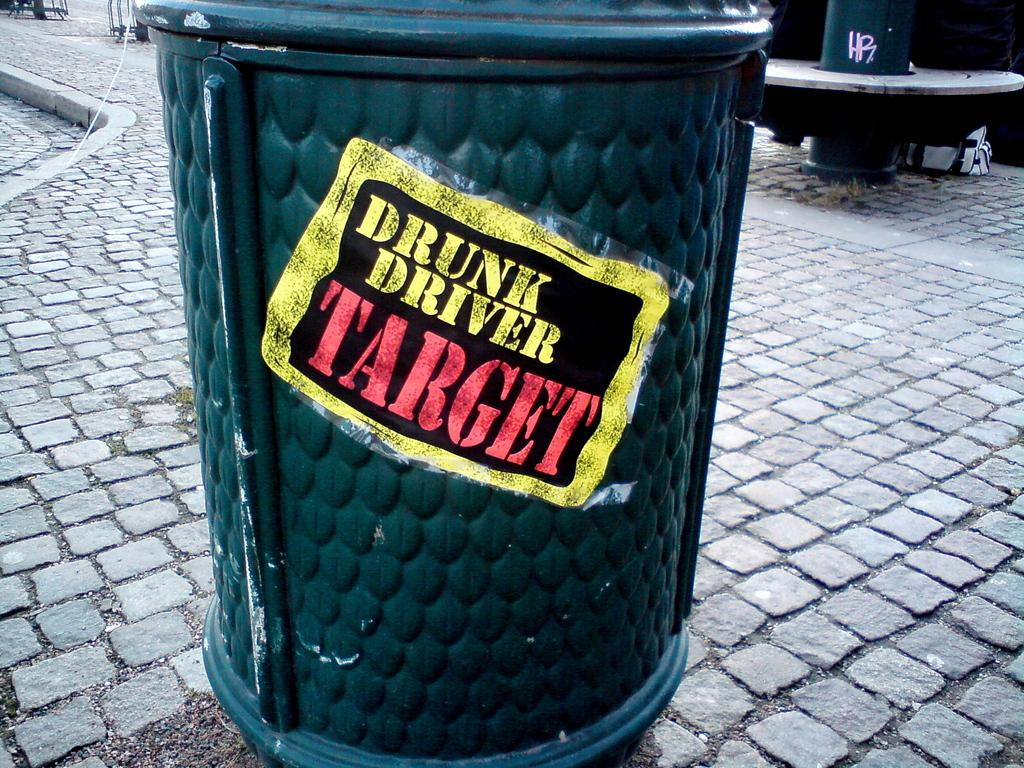<image>
Give a short and clear explanation of the subsequent image. A trash can on the street has the words drunk driver target on the side. 